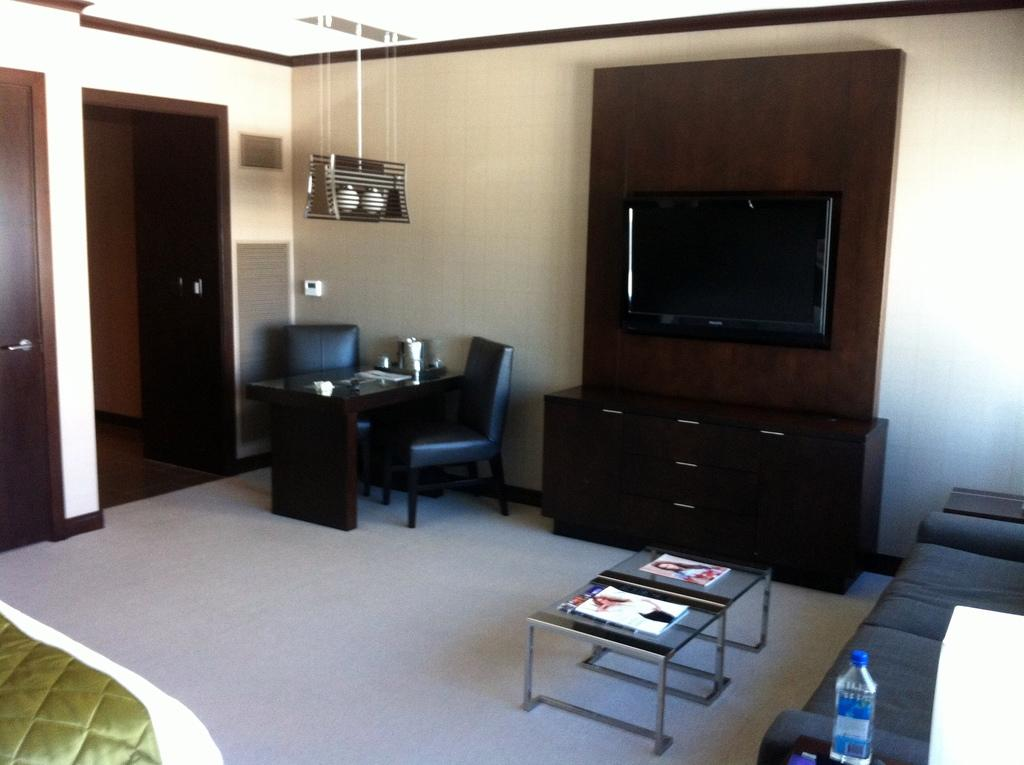What type of space is shown in the image? The image depicts the interior of a room. What furniture is present in the room? There is a bed, a table, chairs, a television, and a sofa in the room. What can be found on the table in the room? There are books on the table in the room. Is there any beverage visible in the room? Yes, there is a water bottle in the room. How does the train compare to the oatmeal in the image? There is no train or oatmeal present in the image; it only shows the interior of a room with various furniture and objects. 